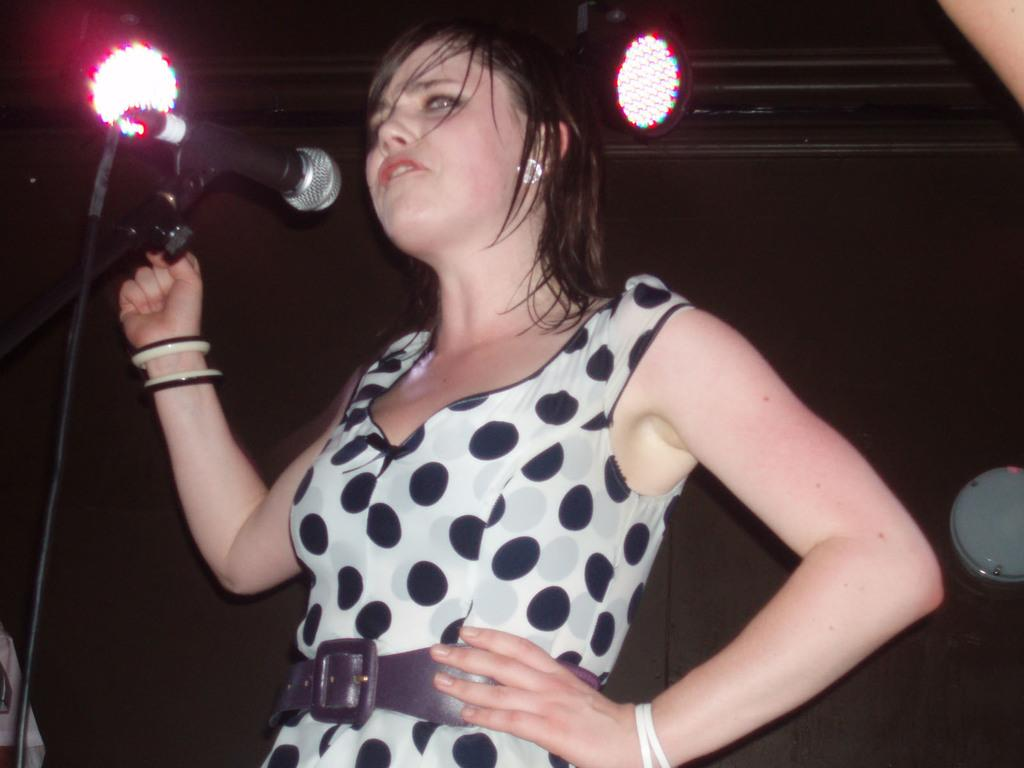Who is the main subject in the image? There is a girl in the image. What is the girl wearing? The girl is wearing a dress. How is the girl described in the image? The girl is stunning. What equipment can be seen to the left side of the image? There is a microphone placed on a stand to the left side of the image. What can be seen in the background of the image? There are two lights in the background of the image. What type of tin can be seen in the image? There is no tin present in the image. Is there a stranger interacting with the girl in the image? There is no stranger present in the image; it only features the girl. 